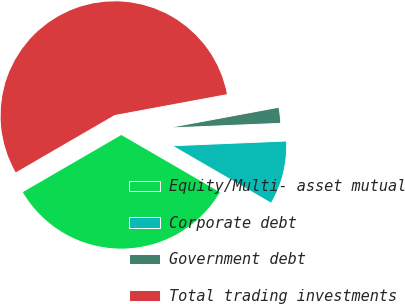Convert chart. <chart><loc_0><loc_0><loc_500><loc_500><pie_chart><fcel>Equity/Multi- asset mutual<fcel>Corporate debt<fcel>Government debt<fcel>Total trading investments<nl><fcel>33.26%<fcel>9.03%<fcel>2.26%<fcel>55.44%<nl></chart> 